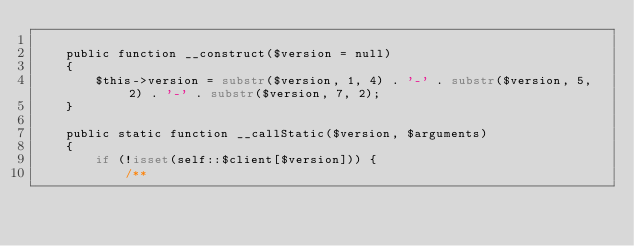Convert code to text. <code><loc_0><loc_0><loc_500><loc_500><_PHP_>
    public function __construct($version = null)
    {
        $this->version = substr($version, 1, 4) . '-' . substr($version, 5, 2) . '-' . substr($version, 7, 2);
    }

    public static function __callStatic($version, $arguments)
    {
        if (!isset(self::$client[$version])) {
            /**</code> 